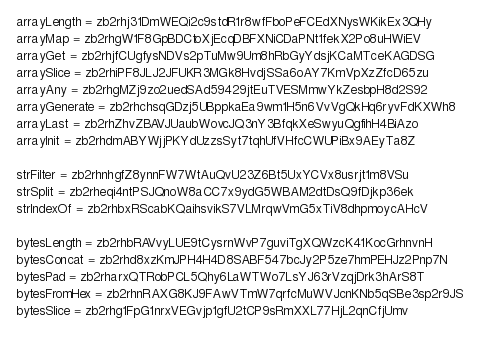Convert code to text. <code><loc_0><loc_0><loc_500><loc_500><_MoonScript_>arrayLength = zb2rhj31DmWEQi2c9stdR1r8wfFboPeFCEdXNysWKikEx3QHy
arrayMap = zb2rhgW1F8GpBDCtoXjEcqDBFXNiCDaPNt1fekX2Po8uHWiEV
arrayGet = zb2rhjfCUgfysNDVs2pTuMw9Um8hRbGyYdsjKCaMTceKAGDSG
arraySlice = zb2rhiPF8JLJ2JFUKR3MGk8HvdjSSa6oAY7KmVpXzZfcD65zu
arrayAny = zb2rhgMZj9zo2uedSAd59429jtEuTVESMmwYkZesbpH8d2S92
arrayGenerate = zb2rhchsqGDzj5UBppkaEa9wm1H5n6VvVgQkHq6ryvFdKXWh8
arrayLast = zb2rhZhvZBAVJUaubWovcJQ3nY3BfqkXeSwyuQgfihH4BiAzo
arrayInit = zb2rhdmABYWjjPKYdUzzsSyt7tqhUfVHfcCWUPiBx9AEyTa8Z

strFilter = zb2rhnhgfZ8ynnFW7WtAuQvU23Z6Bt5UxYCVx8usrjt1m8VSu
strSplit = zb2rheqi4ntPSJQnoW8aCC7x9ydG5WBAM2dtDsQ9fDjkp36ek
strIndexOf = zb2rhbxRScabKQaihsvikS7VLMrqwVmG5xTiV8dhpmoycAHcV

bytesLength = zb2rhbRAVvyLUE9tCysrnWvP7guviTgXQWzcK41KocGrhnvnH
bytesConcat = zb2rhd8xzKmJPH4H4D8SABF547bcJy2P5ze7hmPEHJz2Pnp7N
bytesPad = zb2rharxQTRobPCL5Qhy6LaWTWo7LsYJ63rVzqjDrk3hArS8T
bytesFromHex = zb2rhnRAXG8KJ9FAwVTmW7qrfcMuWVJcnKNb5qSBe3sp2r9JS
bytesSlice = zb2rhg1FpG1nrxVEGvjp1gfU2tCP9sRmXXL77HjL2qnCfjUmv</code> 